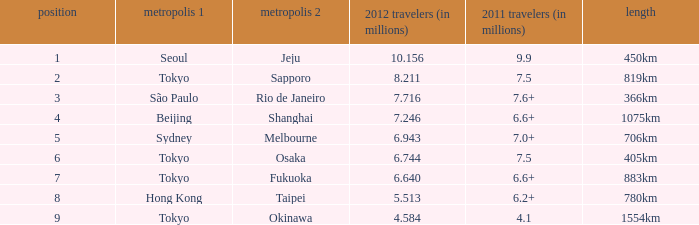Could you parse the entire table as a dict? {'header': ['position', 'metropolis 1', 'metropolis 2', '2012 travelers (in millions)', '2011 travelers (in millions)', 'length'], 'rows': [['1', 'Seoul', 'Jeju', '10.156', '9.9', '450km'], ['2', 'Tokyo', 'Sapporo', '8.211', '7.5', '819km'], ['3', 'São Paulo', 'Rio de Janeiro', '7.716', '7.6+', '366km'], ['4', 'Beijing', 'Shanghai', '7.246', '6.6+', '1075km'], ['5', 'Sydney', 'Melbourne', '6.943', '7.0+', '706km'], ['6', 'Tokyo', 'Osaka', '6.744', '7.5', '405km'], ['7', 'Tokyo', 'Fukuoka', '6.640', '6.6+', '883km'], ['8', 'Hong Kong', 'Taipei', '5.513', '6.2+', '780km'], ['9', 'Tokyo', 'Okinawa', '4.584', '4.1', '1554km']]} How many passengers (in millions) flew from Seoul in 2012? 10.156. 